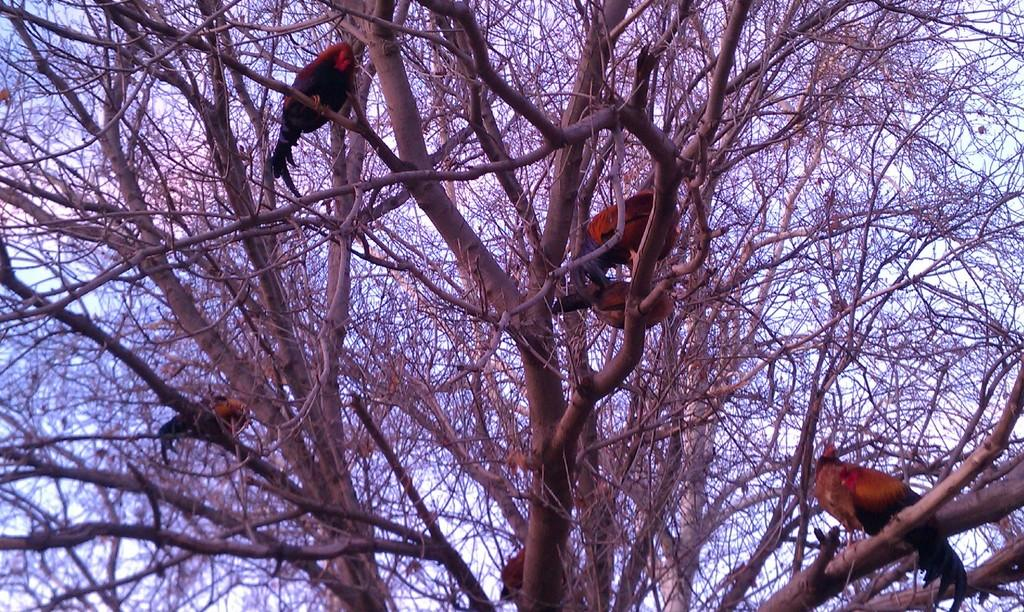What type of animals can be seen in the image? There are birds in the image. Where are the birds located? The birds are on the branches of a tree. What is visible in the background of the image? There is sky visible in the background of the image. What type of ear can be seen on the birds in the image? Birds do not have ears like humans, so there is no visible ear on the birds in the image. 